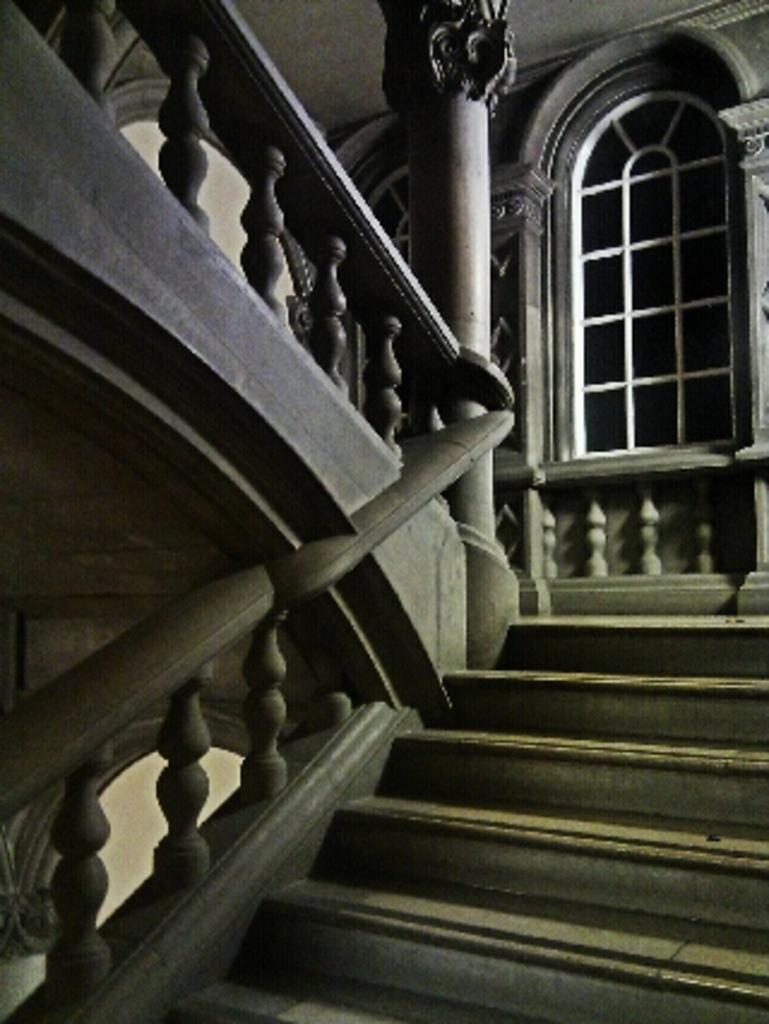What is the lighting condition in the image? The image is taken in the dark. What can be seen on the left side of the image? There are stairs on the left side of the image. What architectural feature is present in the image? There is a window in the image. What is the pole in the image used for? The purpose of the pole in the image is not specified, but it could be used for support or as a part of a structure. What is on the right side of the image? There is a wall on the right side of the image. What type of cup is being used to apply paste on the wall in the image? There is no cup or paste present in the image; it only features stairs, a window, a pole, and a wall. 